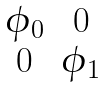<formula> <loc_0><loc_0><loc_500><loc_500>\begin{matrix} \phi _ { 0 } & 0 \\ 0 & \phi _ { 1 } \end{matrix}</formula> 